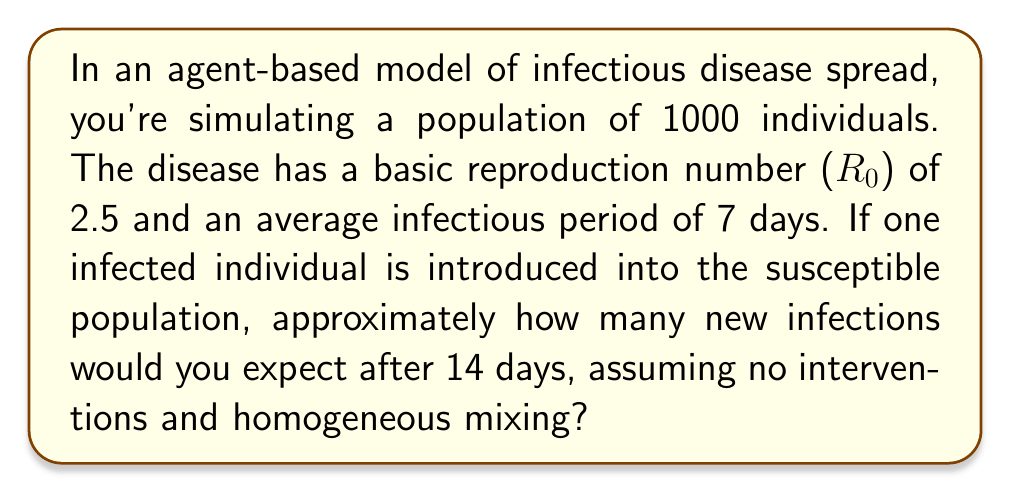Can you answer this question? To solve this problem, we'll use the concept of exponential growth in the early stages of an epidemic. We'll follow these steps:

1) The basic reproduction number ($R_0$) represents the average number of secondary infections caused by one infected individual in a fully susceptible population. Here, $R_0 = 2.5$.

2) The generation time (time between successive generations of infections) is approximately equal to the infectious period, which is 7 days.

3) In 14 days, we have 2 generations of infection (14 days / 7 days per generation).

4) In an idealized scenario with exponential growth, the number of new infections after $n$ generations is given by:

   $$ \text{New Infections} = R_0^n $$

5) For our scenario:
   $$ \text{New Infections} = 2.5^2 = 6.25 $$

6) However, this is a continuous value. In a real-world scenario with discrete individuals, we need to round this to the nearest whole number.

7) Therefore, we would expect approximately 6 new infections after 14 days.

Note: This is a simplified model and assumes ideal conditions. In a more complex agent-based model, factors such as population heterogeneity, stochasticity, and network effects would influence the actual number of infections.
Answer: 6 new infections 